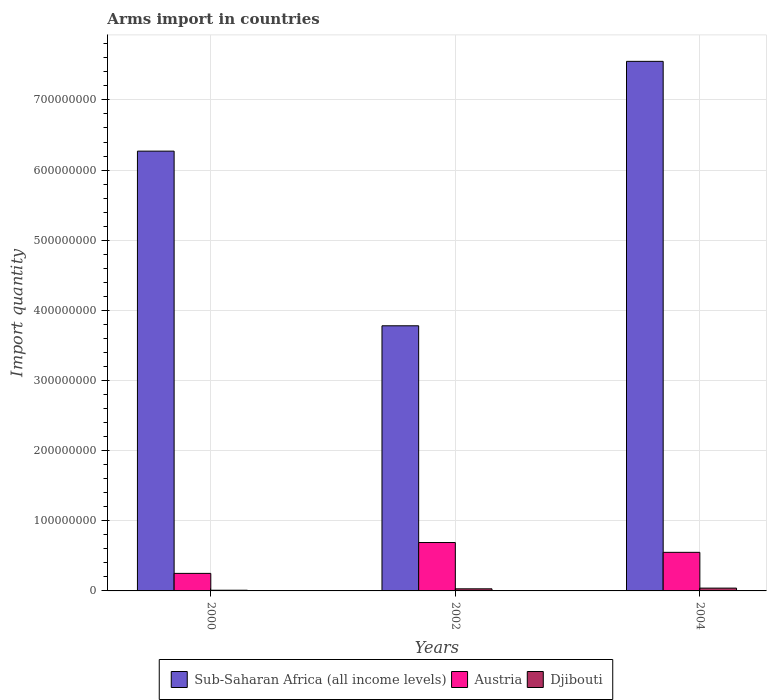How many different coloured bars are there?
Make the answer very short. 3. How many groups of bars are there?
Your response must be concise. 3. Are the number of bars on each tick of the X-axis equal?
Give a very brief answer. Yes. How many bars are there on the 2nd tick from the left?
Ensure brevity in your answer.  3. In how many cases, is the number of bars for a given year not equal to the number of legend labels?
Make the answer very short. 0. What is the total arms import in Sub-Saharan Africa (all income levels) in 2000?
Your response must be concise. 6.27e+08. Across all years, what is the minimum total arms import in Austria?
Offer a terse response. 2.50e+07. In which year was the total arms import in Austria minimum?
Your answer should be compact. 2000. What is the total total arms import in Sub-Saharan Africa (all income levels) in the graph?
Give a very brief answer. 1.76e+09. What is the difference between the total arms import in Austria in 2000 and the total arms import in Djibouti in 2002?
Keep it short and to the point. 2.20e+07. What is the average total arms import in Sub-Saharan Africa (all income levels) per year?
Provide a short and direct response. 5.87e+08. In the year 2000, what is the difference between the total arms import in Austria and total arms import in Sub-Saharan Africa (all income levels)?
Your answer should be very brief. -6.02e+08. Is the difference between the total arms import in Austria in 2002 and 2004 greater than the difference between the total arms import in Sub-Saharan Africa (all income levels) in 2002 and 2004?
Offer a very short reply. Yes. What is the difference between the highest and the second highest total arms import in Sub-Saharan Africa (all income levels)?
Give a very brief answer. 1.28e+08. What is the difference between the highest and the lowest total arms import in Sub-Saharan Africa (all income levels)?
Keep it short and to the point. 3.77e+08. In how many years, is the total arms import in Austria greater than the average total arms import in Austria taken over all years?
Provide a short and direct response. 2. What does the 3rd bar from the left in 2000 represents?
Offer a terse response. Djibouti. What does the 1st bar from the right in 2004 represents?
Ensure brevity in your answer.  Djibouti. Is it the case that in every year, the sum of the total arms import in Djibouti and total arms import in Austria is greater than the total arms import in Sub-Saharan Africa (all income levels)?
Your answer should be very brief. No. How many bars are there?
Your answer should be very brief. 9. What is the difference between two consecutive major ticks on the Y-axis?
Give a very brief answer. 1.00e+08. Does the graph contain any zero values?
Your answer should be compact. No. How many legend labels are there?
Offer a terse response. 3. How are the legend labels stacked?
Make the answer very short. Horizontal. What is the title of the graph?
Make the answer very short. Arms import in countries. Does "Korea (Democratic)" appear as one of the legend labels in the graph?
Offer a terse response. No. What is the label or title of the X-axis?
Your answer should be compact. Years. What is the label or title of the Y-axis?
Your answer should be compact. Import quantity. What is the Import quantity of Sub-Saharan Africa (all income levels) in 2000?
Keep it short and to the point. 6.27e+08. What is the Import quantity in Austria in 2000?
Ensure brevity in your answer.  2.50e+07. What is the Import quantity of Sub-Saharan Africa (all income levels) in 2002?
Offer a very short reply. 3.78e+08. What is the Import quantity in Austria in 2002?
Your answer should be compact. 6.90e+07. What is the Import quantity in Sub-Saharan Africa (all income levels) in 2004?
Offer a very short reply. 7.55e+08. What is the Import quantity of Austria in 2004?
Offer a very short reply. 5.50e+07. What is the Import quantity of Djibouti in 2004?
Offer a very short reply. 4.00e+06. Across all years, what is the maximum Import quantity in Sub-Saharan Africa (all income levels)?
Your answer should be very brief. 7.55e+08. Across all years, what is the maximum Import quantity in Austria?
Your answer should be compact. 6.90e+07. Across all years, what is the maximum Import quantity of Djibouti?
Offer a very short reply. 4.00e+06. Across all years, what is the minimum Import quantity of Sub-Saharan Africa (all income levels)?
Your answer should be compact. 3.78e+08. Across all years, what is the minimum Import quantity in Austria?
Your answer should be compact. 2.50e+07. Across all years, what is the minimum Import quantity of Djibouti?
Keep it short and to the point. 1.00e+06. What is the total Import quantity in Sub-Saharan Africa (all income levels) in the graph?
Your answer should be compact. 1.76e+09. What is the total Import quantity of Austria in the graph?
Provide a short and direct response. 1.49e+08. What is the difference between the Import quantity in Sub-Saharan Africa (all income levels) in 2000 and that in 2002?
Ensure brevity in your answer.  2.49e+08. What is the difference between the Import quantity in Austria in 2000 and that in 2002?
Offer a terse response. -4.40e+07. What is the difference between the Import quantity of Djibouti in 2000 and that in 2002?
Provide a short and direct response. -2.00e+06. What is the difference between the Import quantity in Sub-Saharan Africa (all income levels) in 2000 and that in 2004?
Offer a terse response. -1.28e+08. What is the difference between the Import quantity in Austria in 2000 and that in 2004?
Your response must be concise. -3.00e+07. What is the difference between the Import quantity of Sub-Saharan Africa (all income levels) in 2002 and that in 2004?
Keep it short and to the point. -3.77e+08. What is the difference between the Import quantity in Austria in 2002 and that in 2004?
Offer a very short reply. 1.40e+07. What is the difference between the Import quantity in Sub-Saharan Africa (all income levels) in 2000 and the Import quantity in Austria in 2002?
Keep it short and to the point. 5.58e+08. What is the difference between the Import quantity of Sub-Saharan Africa (all income levels) in 2000 and the Import quantity of Djibouti in 2002?
Give a very brief answer. 6.24e+08. What is the difference between the Import quantity of Austria in 2000 and the Import quantity of Djibouti in 2002?
Keep it short and to the point. 2.20e+07. What is the difference between the Import quantity of Sub-Saharan Africa (all income levels) in 2000 and the Import quantity of Austria in 2004?
Ensure brevity in your answer.  5.72e+08. What is the difference between the Import quantity in Sub-Saharan Africa (all income levels) in 2000 and the Import quantity in Djibouti in 2004?
Your response must be concise. 6.23e+08. What is the difference between the Import quantity in Austria in 2000 and the Import quantity in Djibouti in 2004?
Your answer should be compact. 2.10e+07. What is the difference between the Import quantity in Sub-Saharan Africa (all income levels) in 2002 and the Import quantity in Austria in 2004?
Your response must be concise. 3.23e+08. What is the difference between the Import quantity of Sub-Saharan Africa (all income levels) in 2002 and the Import quantity of Djibouti in 2004?
Your answer should be compact. 3.74e+08. What is the difference between the Import quantity in Austria in 2002 and the Import quantity in Djibouti in 2004?
Your response must be concise. 6.50e+07. What is the average Import quantity in Sub-Saharan Africa (all income levels) per year?
Ensure brevity in your answer.  5.87e+08. What is the average Import quantity of Austria per year?
Give a very brief answer. 4.97e+07. What is the average Import quantity in Djibouti per year?
Offer a very short reply. 2.67e+06. In the year 2000, what is the difference between the Import quantity in Sub-Saharan Africa (all income levels) and Import quantity in Austria?
Offer a very short reply. 6.02e+08. In the year 2000, what is the difference between the Import quantity of Sub-Saharan Africa (all income levels) and Import quantity of Djibouti?
Your response must be concise. 6.26e+08. In the year 2000, what is the difference between the Import quantity in Austria and Import quantity in Djibouti?
Provide a short and direct response. 2.40e+07. In the year 2002, what is the difference between the Import quantity in Sub-Saharan Africa (all income levels) and Import quantity in Austria?
Your response must be concise. 3.09e+08. In the year 2002, what is the difference between the Import quantity in Sub-Saharan Africa (all income levels) and Import quantity in Djibouti?
Your response must be concise. 3.75e+08. In the year 2002, what is the difference between the Import quantity in Austria and Import quantity in Djibouti?
Give a very brief answer. 6.60e+07. In the year 2004, what is the difference between the Import quantity of Sub-Saharan Africa (all income levels) and Import quantity of Austria?
Your answer should be compact. 7.00e+08. In the year 2004, what is the difference between the Import quantity in Sub-Saharan Africa (all income levels) and Import quantity in Djibouti?
Ensure brevity in your answer.  7.51e+08. In the year 2004, what is the difference between the Import quantity in Austria and Import quantity in Djibouti?
Offer a very short reply. 5.10e+07. What is the ratio of the Import quantity in Sub-Saharan Africa (all income levels) in 2000 to that in 2002?
Give a very brief answer. 1.66. What is the ratio of the Import quantity in Austria in 2000 to that in 2002?
Make the answer very short. 0.36. What is the ratio of the Import quantity of Djibouti in 2000 to that in 2002?
Keep it short and to the point. 0.33. What is the ratio of the Import quantity of Sub-Saharan Africa (all income levels) in 2000 to that in 2004?
Provide a succinct answer. 0.83. What is the ratio of the Import quantity in Austria in 2000 to that in 2004?
Your answer should be compact. 0.45. What is the ratio of the Import quantity in Djibouti in 2000 to that in 2004?
Your response must be concise. 0.25. What is the ratio of the Import quantity of Sub-Saharan Africa (all income levels) in 2002 to that in 2004?
Make the answer very short. 0.5. What is the ratio of the Import quantity in Austria in 2002 to that in 2004?
Offer a very short reply. 1.25. What is the difference between the highest and the second highest Import quantity in Sub-Saharan Africa (all income levels)?
Your answer should be very brief. 1.28e+08. What is the difference between the highest and the second highest Import quantity in Austria?
Make the answer very short. 1.40e+07. What is the difference between the highest and the lowest Import quantity in Sub-Saharan Africa (all income levels)?
Your answer should be compact. 3.77e+08. What is the difference between the highest and the lowest Import quantity of Austria?
Make the answer very short. 4.40e+07. What is the difference between the highest and the lowest Import quantity in Djibouti?
Make the answer very short. 3.00e+06. 